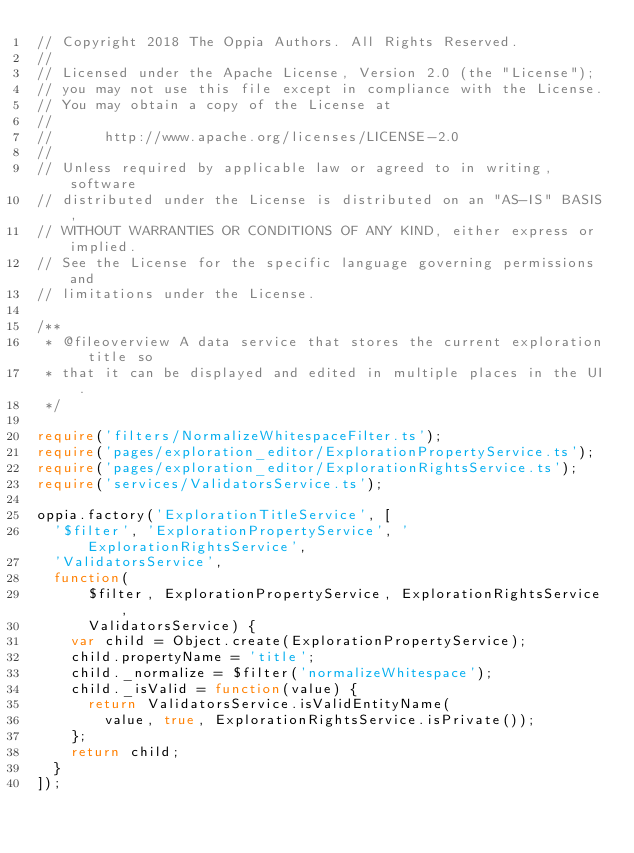Convert code to text. <code><loc_0><loc_0><loc_500><loc_500><_TypeScript_>// Copyright 2018 The Oppia Authors. All Rights Reserved.
//
// Licensed under the Apache License, Version 2.0 (the "License");
// you may not use this file except in compliance with the License.
// You may obtain a copy of the License at
//
//      http://www.apache.org/licenses/LICENSE-2.0
//
// Unless required by applicable law or agreed to in writing, software
// distributed under the License is distributed on an "AS-IS" BASIS,
// WITHOUT WARRANTIES OR CONDITIONS OF ANY KIND, either express or implied.
// See the License for the specific language governing permissions and
// limitations under the License.

/**
 * @fileoverview A data service that stores the current exploration title so
 * that it can be displayed and edited in multiple places in the UI.
 */

require('filters/NormalizeWhitespaceFilter.ts');
require('pages/exploration_editor/ExplorationPropertyService.ts');
require('pages/exploration_editor/ExplorationRightsService.ts');
require('services/ValidatorsService.ts');

oppia.factory('ExplorationTitleService', [
  '$filter', 'ExplorationPropertyService', 'ExplorationRightsService',
  'ValidatorsService',
  function(
      $filter, ExplorationPropertyService, ExplorationRightsService,
      ValidatorsService) {
    var child = Object.create(ExplorationPropertyService);
    child.propertyName = 'title';
    child._normalize = $filter('normalizeWhitespace');
    child._isValid = function(value) {
      return ValidatorsService.isValidEntityName(
        value, true, ExplorationRightsService.isPrivate());
    };
    return child;
  }
]);
</code> 